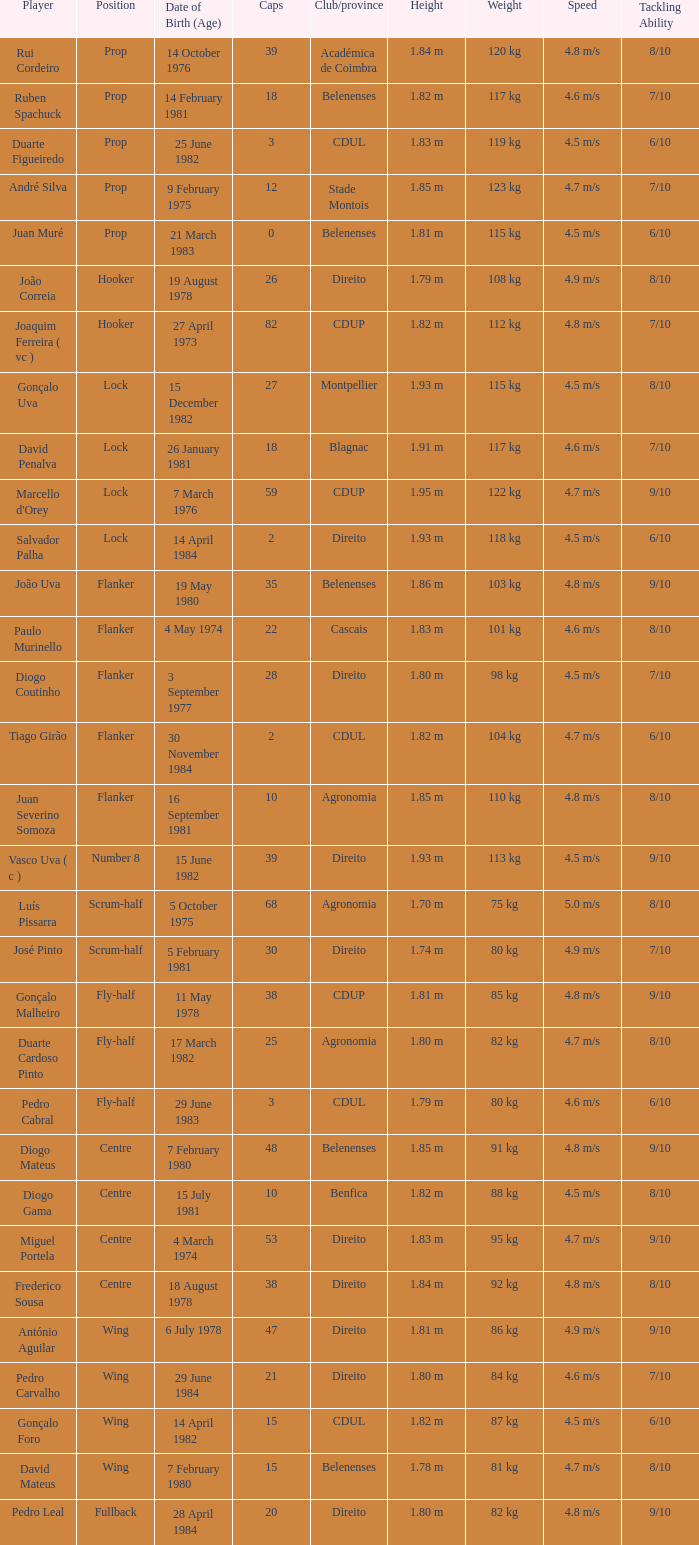Which player has a Position of fly-half, and a Caps of 3? Pedro Cabral. 